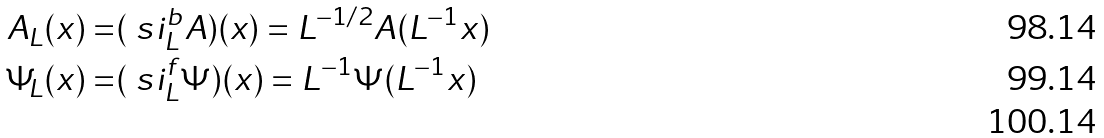<formula> <loc_0><loc_0><loc_500><loc_500>A _ { L } ( x ) = & ( \ s i ^ { b } _ { L } A ) ( x ) = L ^ { - 1 / 2 } A ( L ^ { - 1 } x ) \\ \Psi _ { L } ( x ) = & ( \ s i ^ { f } _ { L } \Psi ) ( x ) = L ^ { - 1 } \Psi ( L ^ { - 1 } x ) \\</formula> 